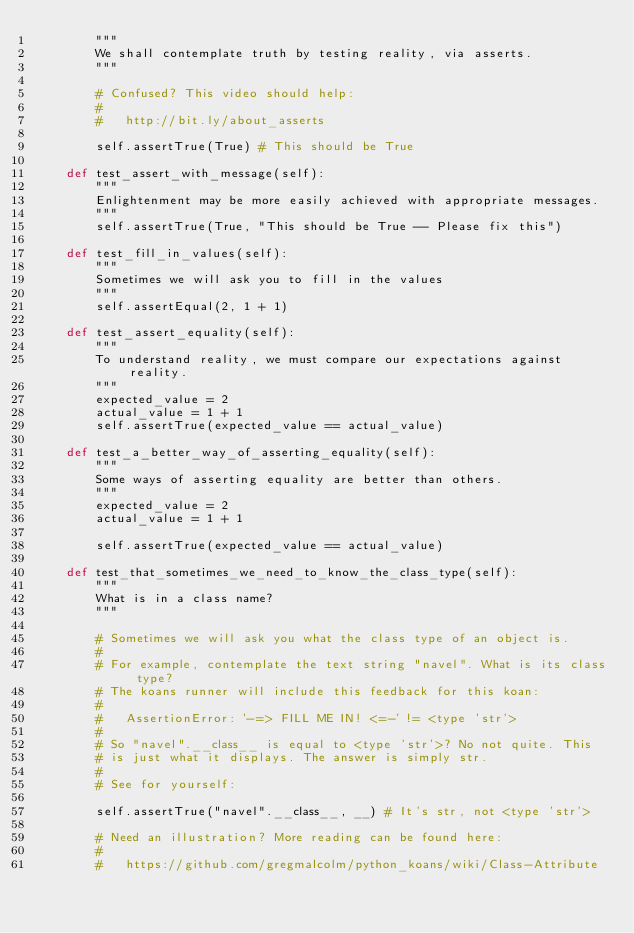Convert code to text. <code><loc_0><loc_0><loc_500><loc_500><_Python_>        """
        We shall contemplate truth by testing reality, via asserts.
        """

        # Confused? This video should help:
        #
        #   http://bit.ly/about_asserts

        self.assertTrue(True) # This should be True

    def test_assert_with_message(self):
        """
        Enlightenment may be more easily achieved with appropriate messages.
        """
        self.assertTrue(True, "This should be True -- Please fix this")

    def test_fill_in_values(self):
        """
        Sometimes we will ask you to fill in the values
        """
        self.assertEqual(2, 1 + 1)

    def test_assert_equality(self):
        """
        To understand reality, we must compare our expectations against reality.
        """
        expected_value = 2
        actual_value = 1 + 1
        self.assertTrue(expected_value == actual_value)

    def test_a_better_way_of_asserting_equality(self):
        """
        Some ways of asserting equality are better than others.
        """
        expected_value = 2
        actual_value = 1 + 1

        self.assertTrue(expected_value == actual_value)

    def test_that_sometimes_we_need_to_know_the_class_type(self):
        """
        What is in a class name?
        """

        # Sometimes we will ask you what the class type of an object is.
        #
        # For example, contemplate the text string "navel". What is its class type?
        # The koans runner will include this feedback for this koan:
        #
        #   AssertionError: '-=> FILL ME IN! <=-' != <type 'str'>
        #
        # So "navel".__class__ is equal to <type 'str'>? No not quite. This
        # is just what it displays. The answer is simply str.
        #
        # See for yourself:

        self.assertTrue("navel".__class__, __) # It's str, not <type 'str'>

        # Need an illustration? More reading can be found here:
        #
        #   https://github.com/gregmalcolm/python_koans/wiki/Class-Attribute

</code> 